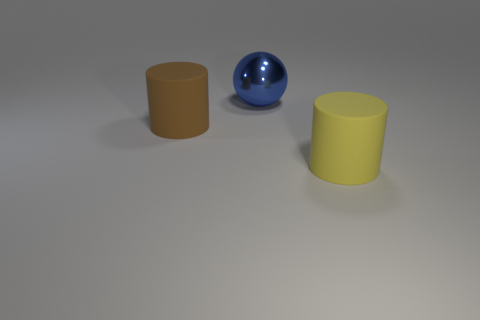Add 2 big yellow cylinders. How many objects exist? 5 Subtract all balls. How many objects are left? 2 Subtract all small purple metal objects. Subtract all large yellow matte things. How many objects are left? 2 Add 2 large brown cylinders. How many large brown cylinders are left? 3 Add 1 tiny cyan objects. How many tiny cyan objects exist? 1 Subtract 0 green cylinders. How many objects are left? 3 